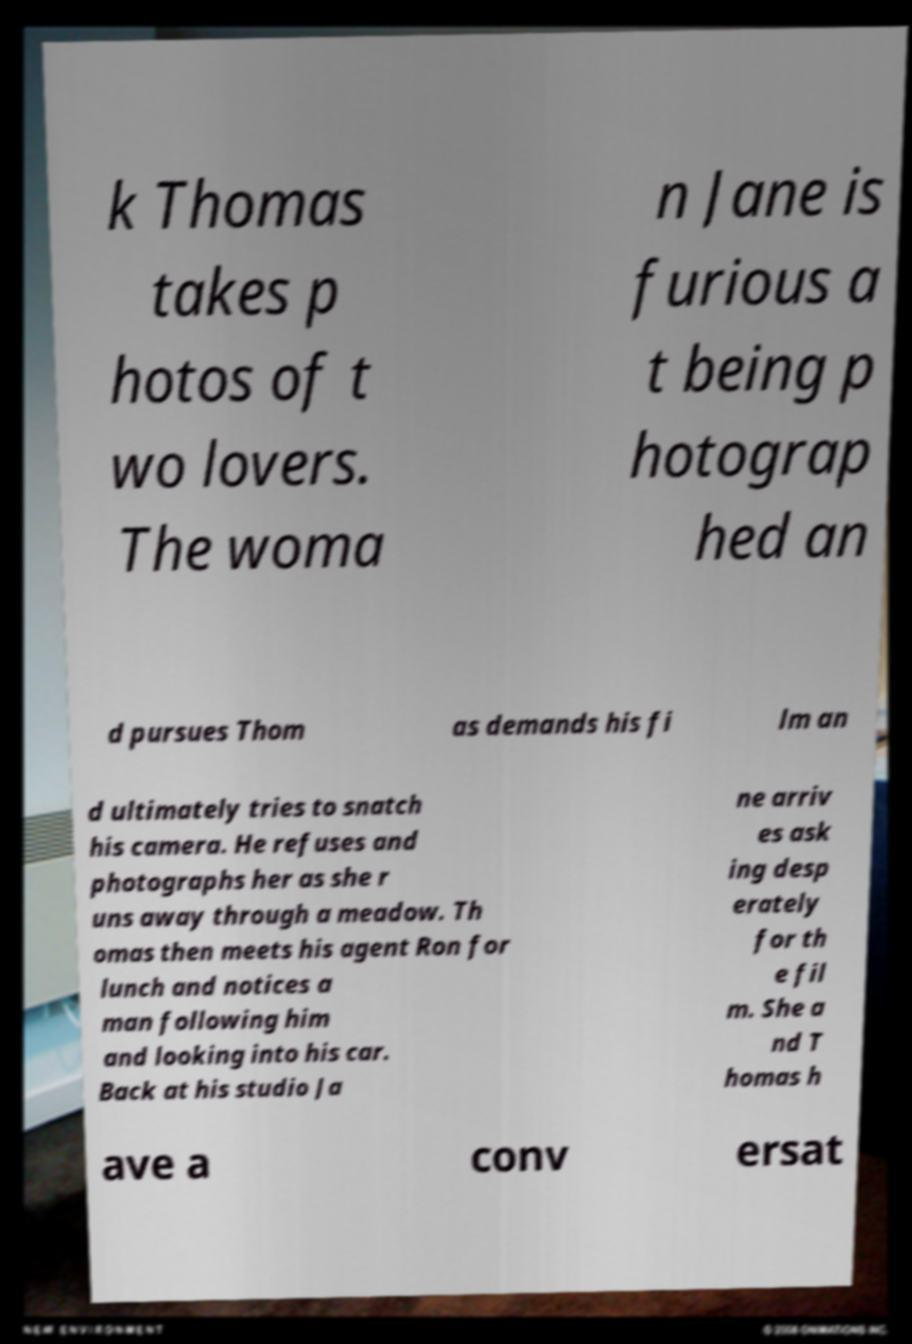Can you accurately transcribe the text from the provided image for me? k Thomas takes p hotos of t wo lovers. The woma n Jane is furious a t being p hotograp hed an d pursues Thom as demands his fi lm an d ultimately tries to snatch his camera. He refuses and photographs her as she r uns away through a meadow. Th omas then meets his agent Ron for lunch and notices a man following him and looking into his car. Back at his studio Ja ne arriv es ask ing desp erately for th e fil m. She a nd T homas h ave a conv ersat 